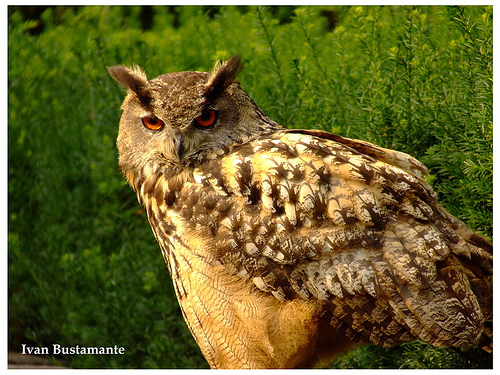Extract all visible text content from this image. Ivan Bustamante 